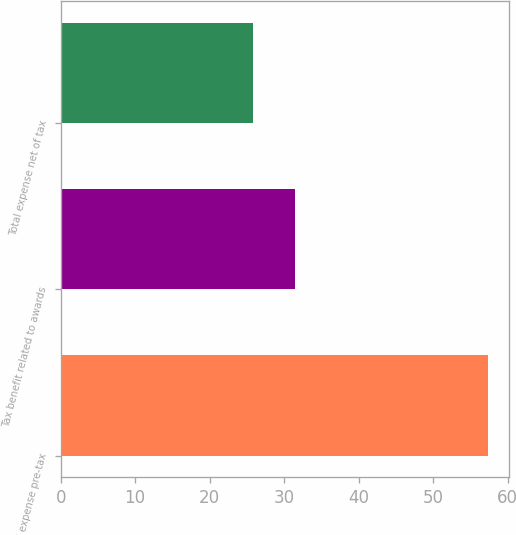Convert chart to OTSL. <chart><loc_0><loc_0><loc_500><loc_500><bar_chart><fcel>Total expense pre-tax<fcel>Tax benefit related to awards<fcel>Total expense net of tax<nl><fcel>57.3<fcel>31.5<fcel>25.8<nl></chart> 